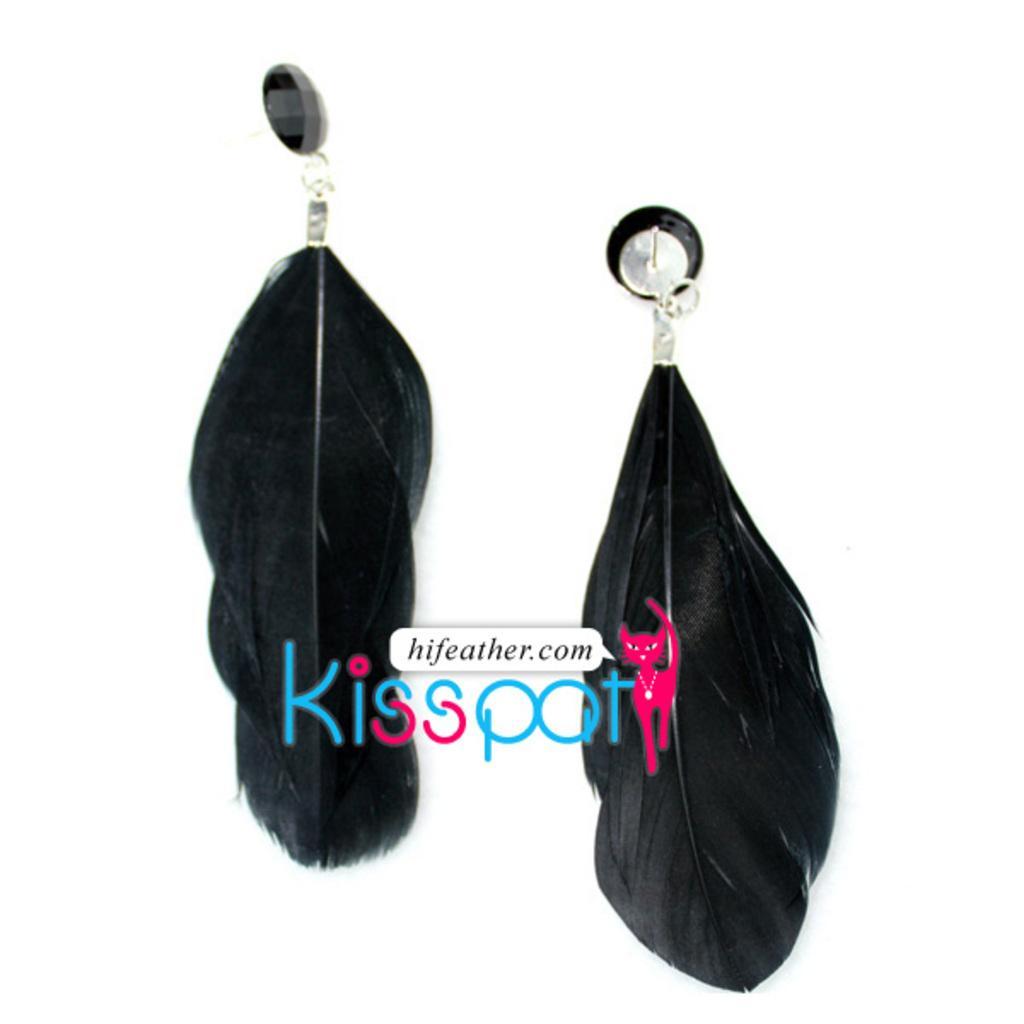In one or two sentences, can you explain what this image depicts? In this image we can see set of earrings. 